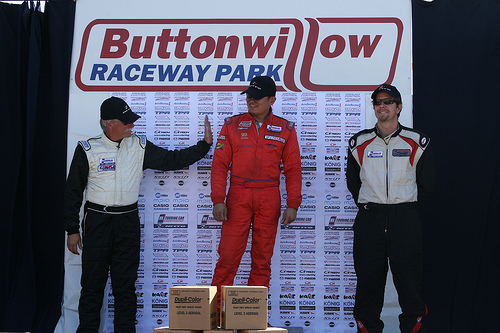<image>
Can you confirm if the box is under the man? Yes. The box is positioned underneath the man, with the man above it in the vertical space. 